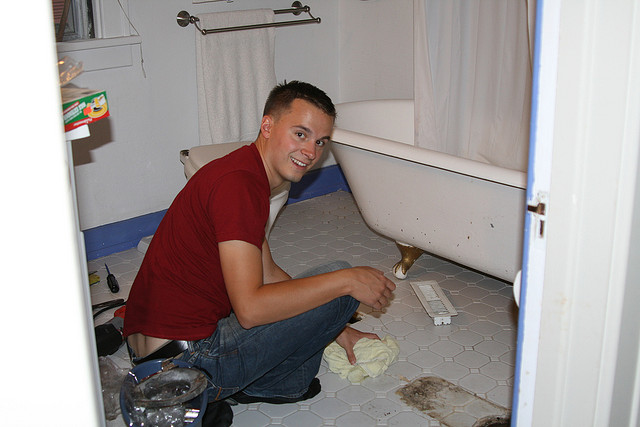Can you describe the main features of this image for me? In this image, we're in a bathroom where a person is sitting on the floor. On the left side of the image, there's a screwdriver lying on the floor near the man's hand. Above the screwdriver and near the wall, we can see a folded towel. To the right, there's a bathtub with a white shower curtain hanging from the top. Another towel is placed on the floor to the right of the bathtub. Above the bathtub, a towel rack with a hanging towel is visible. Below the towel rack and slightly to the left, there's a box on the floor. The man, wearing jeans and a red shirt, is smiling as he appears to be cleaning or fixing something. 